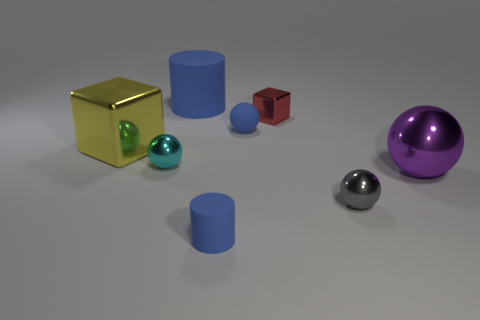Are there any large shiny objects of the same shape as the big blue rubber object?
Your response must be concise. No. Is the shape of the yellow object the same as the red shiny thing?
Offer a very short reply. Yes. There is a rubber cylinder that is in front of the big purple sphere right of the big yellow metal object; what color is it?
Ensure brevity in your answer.  Blue. What color is the cube that is the same size as the gray thing?
Ensure brevity in your answer.  Red. What number of metal objects are either small cyan spheres or purple spheres?
Your answer should be compact. 2. How many red objects are in front of the cylinder that is behind the large yellow block?
Your response must be concise. 1. The other matte cylinder that is the same color as the large cylinder is what size?
Offer a terse response. Small. How many things are big matte cylinders or blue cylinders that are in front of the big purple thing?
Your response must be concise. 2. Is there a red object that has the same material as the cyan sphere?
Your response must be concise. Yes. What number of blue rubber things are both behind the tiny red metal thing and in front of the big block?
Keep it short and to the point. 0. 